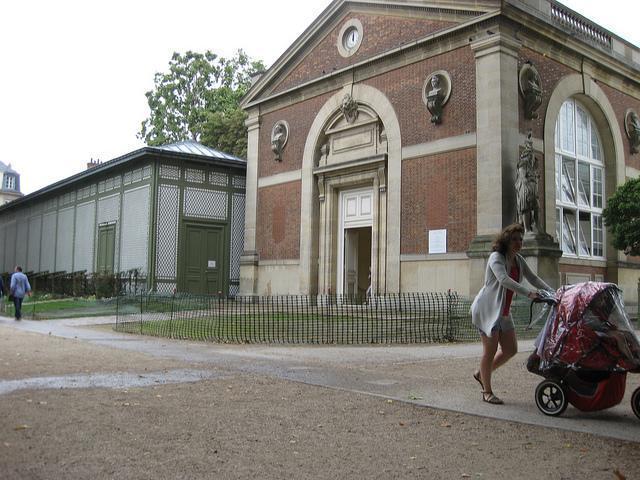How many chairs are under the wood board?
Give a very brief answer. 0. 